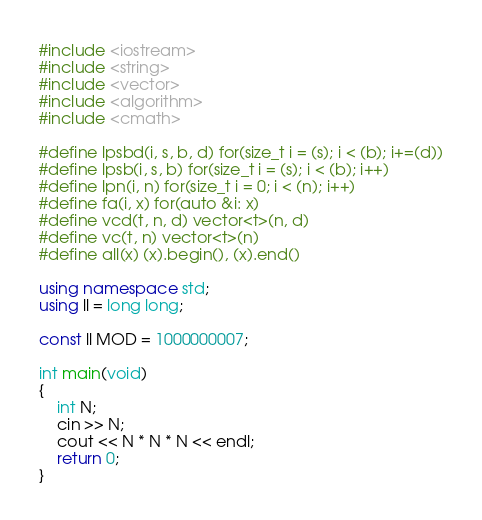<code> <loc_0><loc_0><loc_500><loc_500><_C++_>#include <iostream>
#include <string>
#include <vector>
#include <algorithm>
#include <cmath>

#define lpsbd(i, s, b, d) for(size_t i = (s); i < (b); i+=(d))
#define lpsb(i, s, b) for(size_t i = (s); i < (b); i++)
#define lpn(i, n) for(size_t i = 0; i < (n); i++)
#define fa(i, x) for(auto &i: x)
#define vcd(t, n, d) vector<t>(n, d)
#define vc(t, n) vector<t>(n)
#define all(x) (x).begin(), (x).end()

using namespace std;
using ll = long long;

const ll MOD = 1000000007;

int main(void)
{
    int N;
    cin >> N;
    cout << N * N * N << endl;
    return 0;
}</code> 